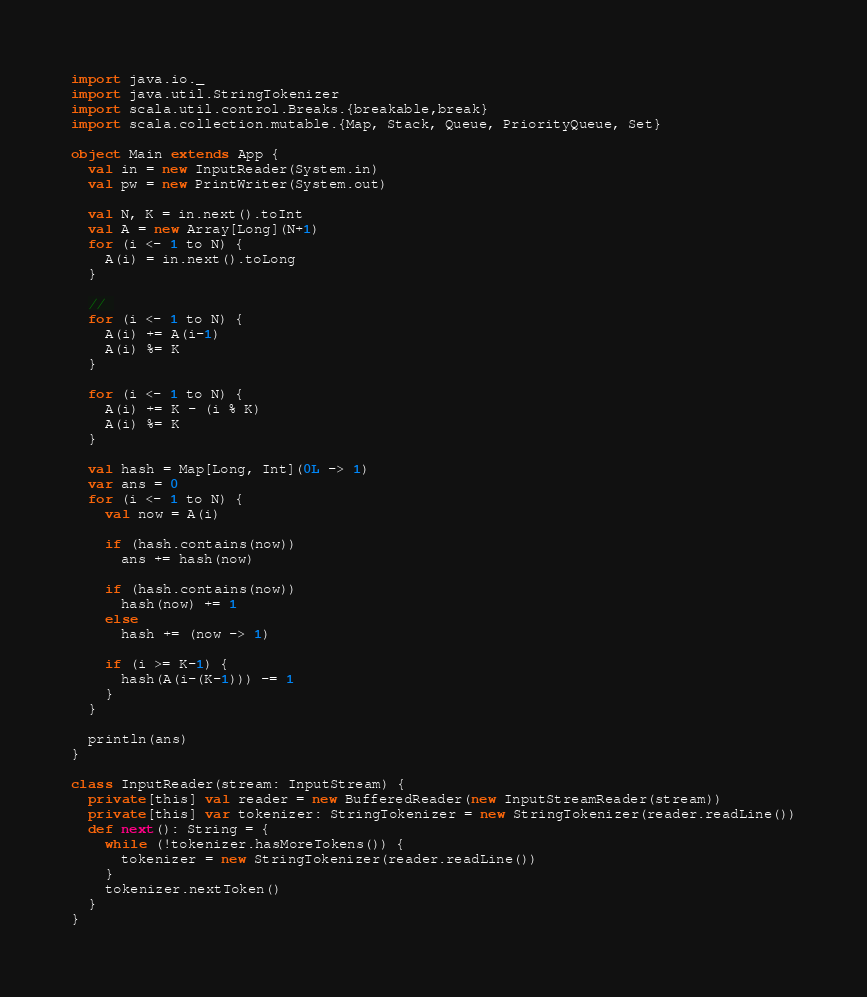<code> <loc_0><loc_0><loc_500><loc_500><_Scala_>import java.io._
import java.util.StringTokenizer
import scala.util.control.Breaks.{breakable,break}
import scala.collection.mutable.{Map, Stack, Queue, PriorityQueue, Set}

object Main extends App {
  val in = new InputReader(System.in)
  val pw = new PrintWriter(System.out)

  val N, K = in.next().toInt
  val A = new Array[Long](N+1)
  for (i <- 1 to N) {
    A(i) = in.next().toLong
  }

  // 
  for (i <- 1 to N) {
    A(i) += A(i-1)
    A(i) %= K
  }

  for (i <- 1 to N) {
    A(i) += K - (i % K)
    A(i) %= K
  }

  val hash = Map[Long, Int](0L -> 1)
  var ans = 0
  for (i <- 1 to N) {
    val now = A(i)

    if (hash.contains(now))
      ans += hash(now)

    if (hash.contains(now))
      hash(now) += 1
    else
      hash += (now -> 1)

    if (i >= K-1) {
      hash(A(i-(K-1))) -= 1
    }
  }

  println(ans)
}

class InputReader(stream: InputStream) {
  private[this] val reader = new BufferedReader(new InputStreamReader(stream))
  private[this] var tokenizer: StringTokenizer = new StringTokenizer(reader.readLine())
  def next(): String = {
    while (!tokenizer.hasMoreTokens()) {
      tokenizer = new StringTokenizer(reader.readLine())
    }
    tokenizer.nextToken()
  }
}
</code> 